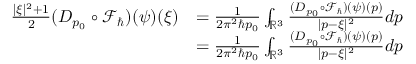Convert formula to latex. <formula><loc_0><loc_0><loc_500><loc_500>\begin{array} { r l } { \frac { | \xi | ^ { 2 } + 1 } { 2 } ( D _ { p _ { 0 } } \circ \mathcal { F } _ { } ) ( \psi ) ( \xi ) } & { = \frac { 1 } { 2 \pi ^ { 2 } \hbar { p } _ { 0 } } \int _ { \mathbb { R } ^ { 3 } } \frac { ( D _ { p _ { 0 } } \circ \mathcal { F } _ { } ) ( \psi ) ( p ) } { | p - \xi | ^ { 2 } } d p } \\ & { = \frac { 1 } { 2 \pi ^ { 2 } \hbar { p } _ { 0 } } \int _ { \mathbb { R } ^ { 3 } } \frac { ( D _ { p _ { 0 } } \circ \mathcal { F } _ { } ) ( \psi ) ( p ) } { | p - \xi | ^ { 2 } } d p } \end{array}</formula> 